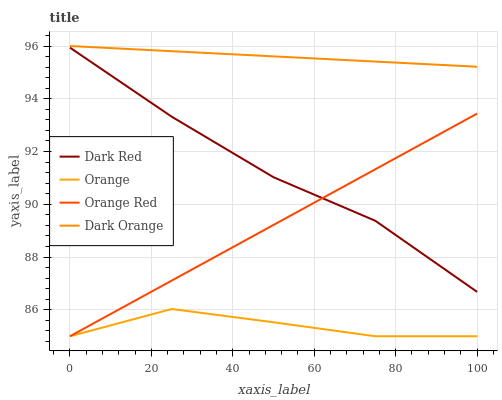Does Orange have the minimum area under the curve?
Answer yes or no. Yes. Does Dark Orange have the maximum area under the curve?
Answer yes or no. Yes. Does Dark Red have the minimum area under the curve?
Answer yes or no. No. Does Dark Red have the maximum area under the curve?
Answer yes or no. No. Is Dark Orange the smoothest?
Answer yes or no. Yes. Is Orange the roughest?
Answer yes or no. Yes. Is Dark Red the smoothest?
Answer yes or no. No. Is Dark Red the roughest?
Answer yes or no. No. Does Dark Red have the lowest value?
Answer yes or no. No. Does Dark Orange have the highest value?
Answer yes or no. Yes. Does Dark Red have the highest value?
Answer yes or no. No. Is Orange Red less than Dark Orange?
Answer yes or no. Yes. Is Dark Red greater than Orange?
Answer yes or no. Yes. Does Orange Red intersect Dark Red?
Answer yes or no. Yes. Is Orange Red less than Dark Red?
Answer yes or no. No. Is Orange Red greater than Dark Red?
Answer yes or no. No. Does Orange Red intersect Dark Orange?
Answer yes or no. No. 